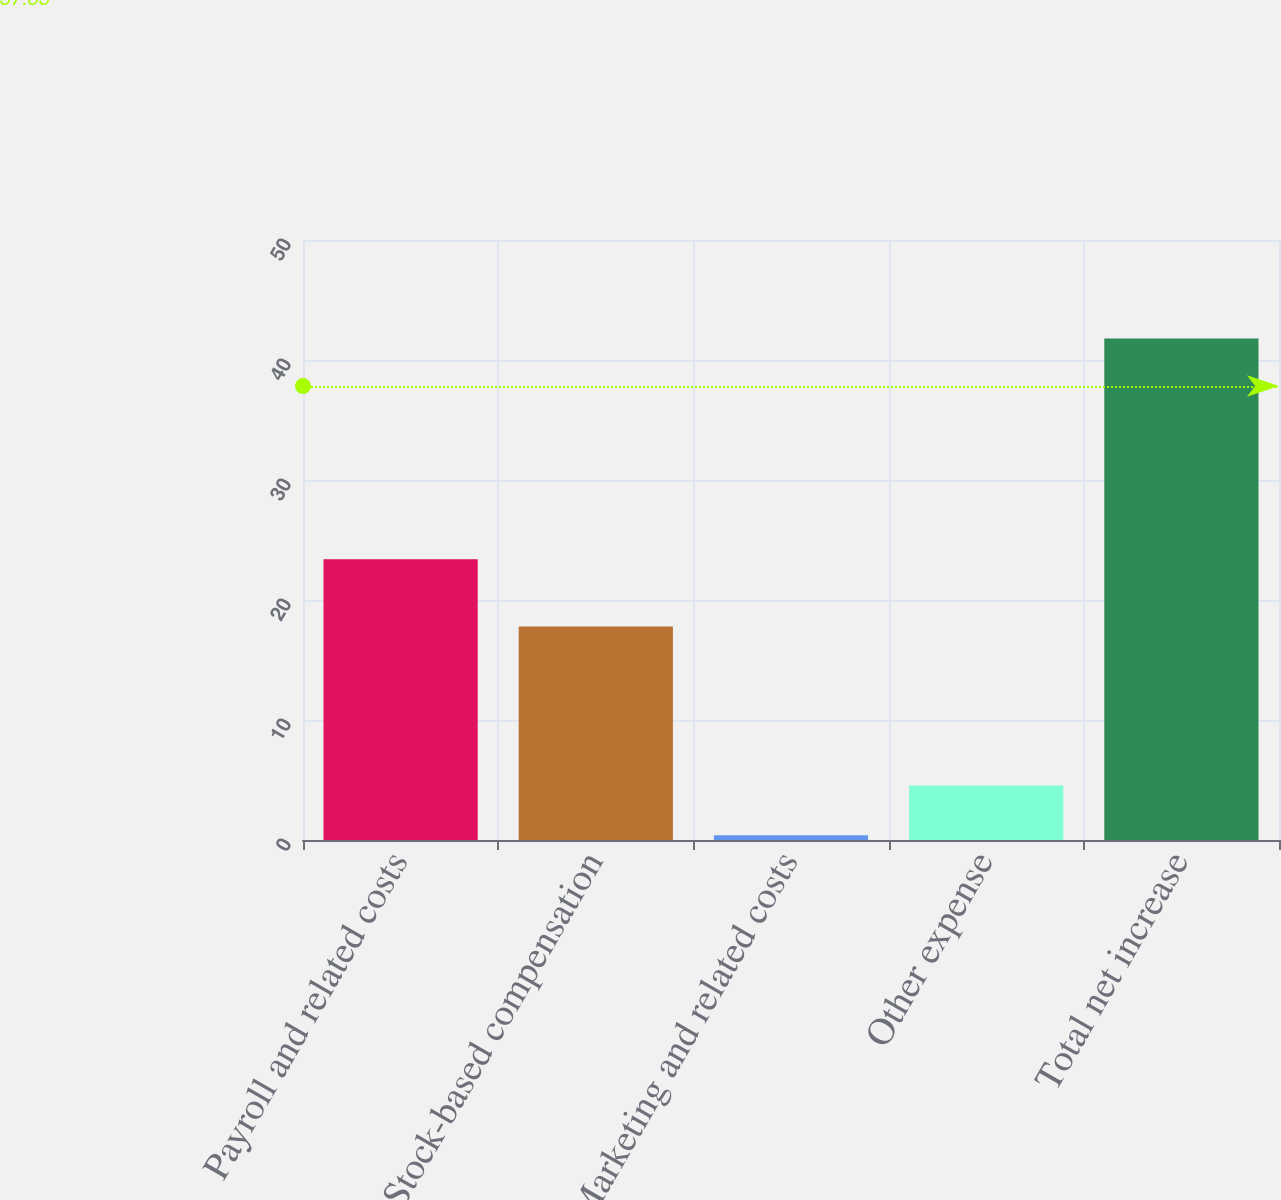Convert chart to OTSL. <chart><loc_0><loc_0><loc_500><loc_500><bar_chart><fcel>Payroll and related costs<fcel>Stock-based compensation<fcel>Marketing and related costs<fcel>Other expense<fcel>Total net increase<nl><fcel>23.4<fcel>17.8<fcel>0.4<fcel>4.54<fcel>41.8<nl></chart> 